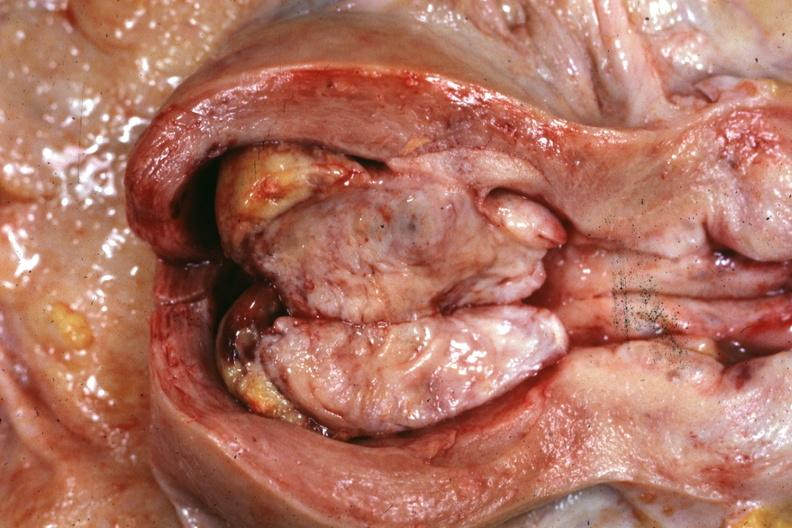s mixed mesodermal tumor present?
Answer the question using a single word or phrase. Yes 